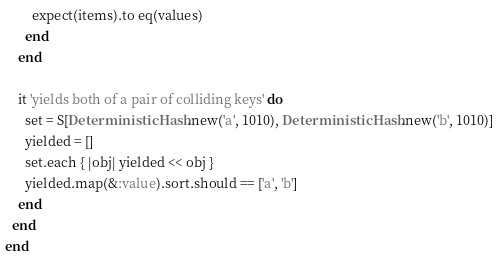<code> <loc_0><loc_0><loc_500><loc_500><_Ruby_>        expect(items).to eq(values)
      end
    end

    it 'yields both of a pair of colliding keys' do
      set = S[DeterministicHash.new('a', 1010), DeterministicHash.new('b', 1010)]
      yielded = []
      set.each { |obj| yielded << obj }
      yielded.map(&:value).sort.should == ['a', 'b']
    end
  end
end
</code> 